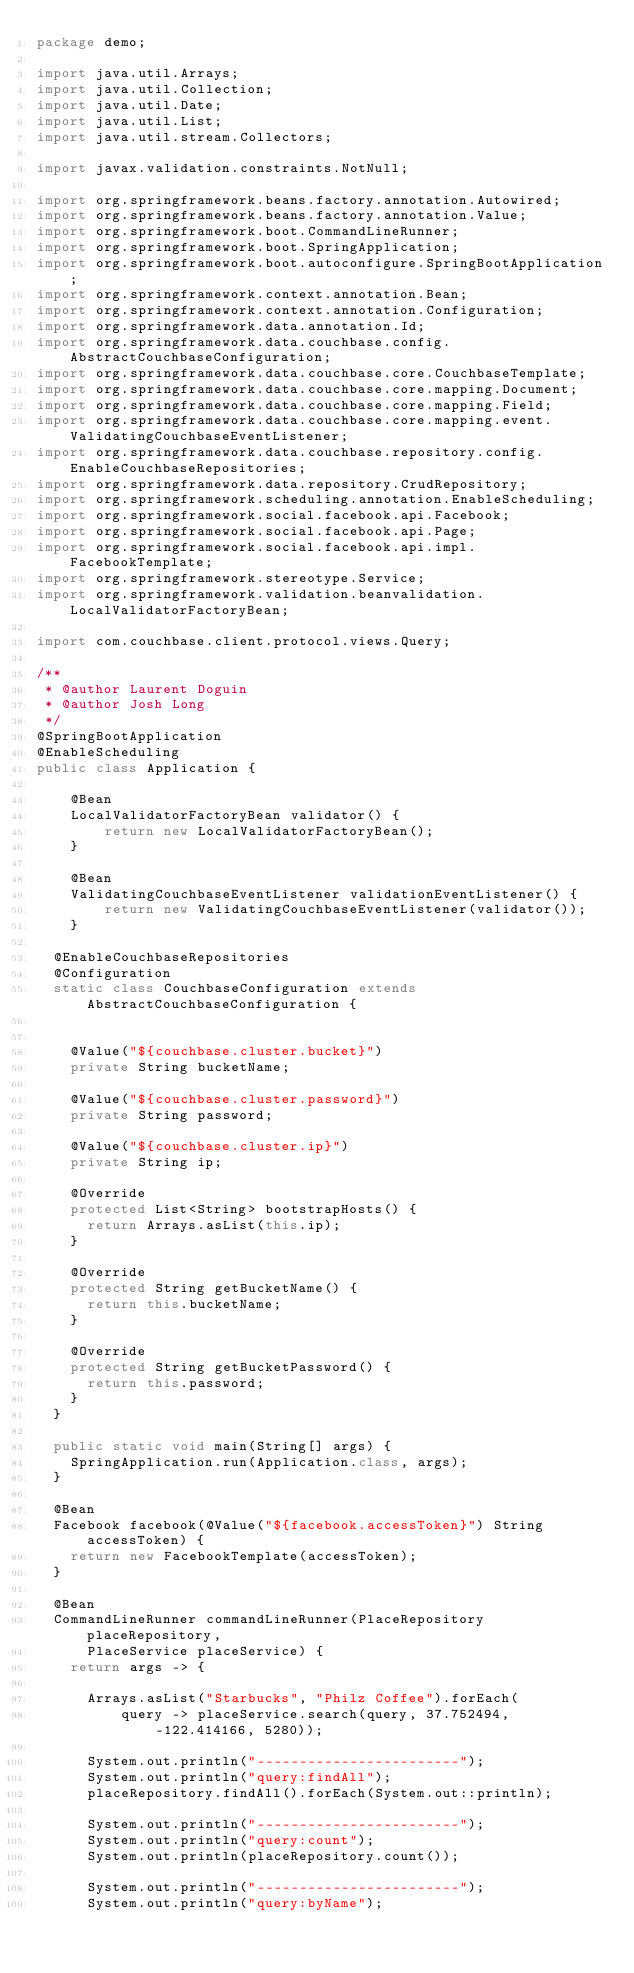Convert code to text. <code><loc_0><loc_0><loc_500><loc_500><_Java_>package demo;

import java.util.Arrays;
import java.util.Collection;
import java.util.Date;
import java.util.List;
import java.util.stream.Collectors;

import javax.validation.constraints.NotNull;

import org.springframework.beans.factory.annotation.Autowired;
import org.springframework.beans.factory.annotation.Value;
import org.springframework.boot.CommandLineRunner;
import org.springframework.boot.SpringApplication;
import org.springframework.boot.autoconfigure.SpringBootApplication;
import org.springframework.context.annotation.Bean;
import org.springframework.context.annotation.Configuration;
import org.springframework.data.annotation.Id;
import org.springframework.data.couchbase.config.AbstractCouchbaseConfiguration;
import org.springframework.data.couchbase.core.CouchbaseTemplate;
import org.springframework.data.couchbase.core.mapping.Document;
import org.springframework.data.couchbase.core.mapping.Field;
import org.springframework.data.couchbase.core.mapping.event.ValidatingCouchbaseEventListener;
import org.springframework.data.couchbase.repository.config.EnableCouchbaseRepositories;
import org.springframework.data.repository.CrudRepository;
import org.springframework.scheduling.annotation.EnableScheduling;
import org.springframework.social.facebook.api.Facebook;
import org.springframework.social.facebook.api.Page;
import org.springframework.social.facebook.api.impl.FacebookTemplate;
import org.springframework.stereotype.Service;
import org.springframework.validation.beanvalidation.LocalValidatorFactoryBean;

import com.couchbase.client.protocol.views.Query;

/**
 * @author Laurent Doguin
 * @author Josh Long
 */
@SpringBootApplication
@EnableScheduling
public class Application {

    @Bean
    LocalValidatorFactoryBean validator() {
        return new LocalValidatorFactoryBean();
    }

    @Bean
    ValidatingCouchbaseEventListener validationEventListener() {
        return new ValidatingCouchbaseEventListener(validator());
    }

	@EnableCouchbaseRepositories
	@Configuration
	static class CouchbaseConfiguration extends AbstractCouchbaseConfiguration {


		@Value("${couchbase.cluster.bucket}")
		private String bucketName;

		@Value("${couchbase.cluster.password}")
		private String password;

		@Value("${couchbase.cluster.ip}")
		private String ip;

		@Override
		protected List<String> bootstrapHosts() {
			return Arrays.asList(this.ip);
		}

		@Override
		protected String getBucketName() {
			return this.bucketName;
		}

		@Override
		protected String getBucketPassword() {
			return this.password;
		}
	}

	public static void main(String[] args) {
		SpringApplication.run(Application.class, args);
	}

	@Bean
	Facebook facebook(@Value("${facebook.accessToken}") String accessToken) {
		return new FacebookTemplate(accessToken);
	}

	@Bean
	CommandLineRunner commandLineRunner(PlaceRepository placeRepository,
			PlaceService placeService) {
		return args -> {

			Arrays.asList("Starbucks", "Philz Coffee").forEach(
					query -> placeService.search(query, 37.752494, -122.414166, 5280));

			System.out.println("------------------------");
			System.out.println("query:findAll");
			placeRepository.findAll().forEach(System.out::println);

			System.out.println("------------------------");
			System.out.println("query:count");
			System.out.println(placeRepository.count());

			System.out.println("------------------------");
			System.out.println("query:byName");</code> 